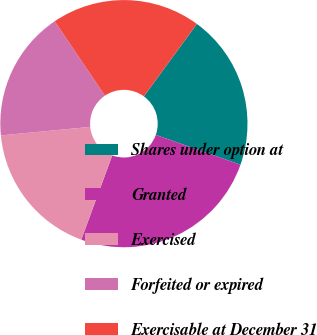Convert chart. <chart><loc_0><loc_0><loc_500><loc_500><pie_chart><fcel>Shares under option at<fcel>Granted<fcel>Exercised<fcel>Forfeited or expired<fcel>Exercisable at December 31<nl><fcel>20.33%<fcel>25.22%<fcel>17.88%<fcel>17.06%<fcel>19.52%<nl></chart> 